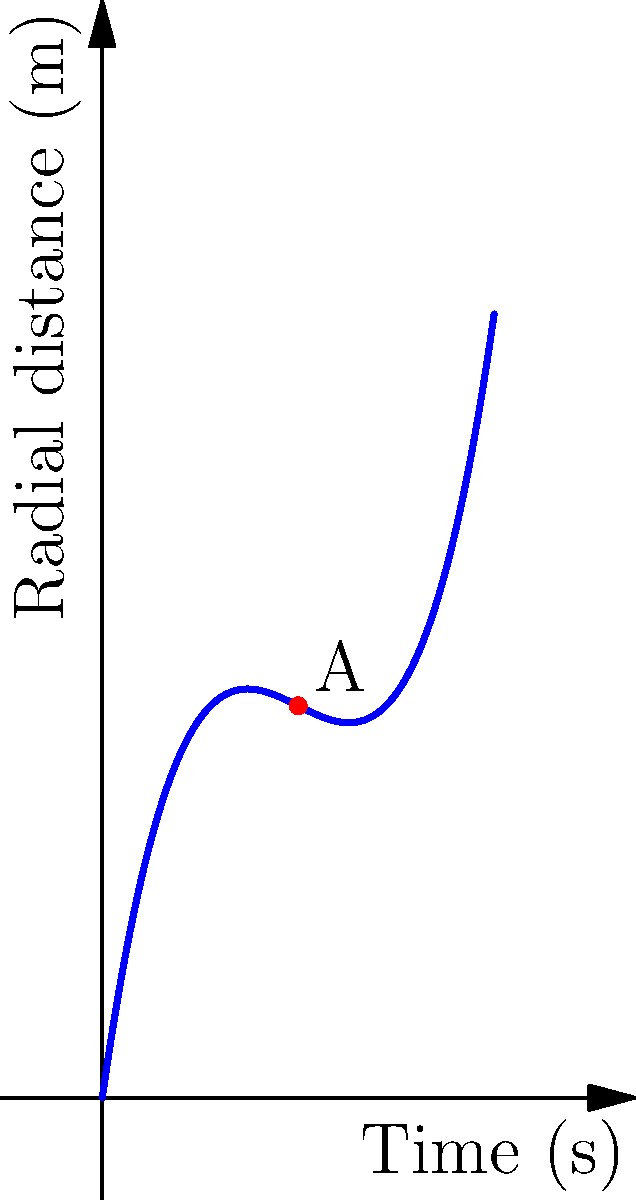A figure skater's spiral path during a spin is modeled by the polynomial function $r(t) = 0.1t^3 - 1.5t^2 + 7t$, where $r$ is the radial distance in meters and $t$ is the time in seconds. At point A on the graph, what is the skater's radial distance from the center of the spin, and how does this relate to the visual composition of the movement? To solve this problem, we'll follow these steps:

1) Point A corresponds to $t = 5$ seconds on the graph.

2) To find the radial distance at this point, we need to evaluate $r(5)$:

   $r(5) = 0.1(5^3) - 1.5(5^2) + 7(5)$

3) Let's calculate each term:
   - $0.1(5^3) = 0.1(125) = 12.5$
   - $1.5(5^2) = 1.5(25) = 37.5$
   - $7(5) = 35$

4) Now, let's combine these terms:
   $r(5) = 12.5 - 37.5 + 35 = 10$ meters

5) Relating to visual composition:
   - The skater is 10 meters from the center at this point.
   - This distance creates a wide, expansive movement in the visual field.
   - The curve's shape suggests a decelerating outward spiral, which could create an interesting contrast of speed and distance in a sketch.
   - The gradual change in radial distance over time allows for capturing the fluidity of the motion in artistic representation.
Answer: 10 meters; creates wide, expansive movement with decelerating outward spiral 